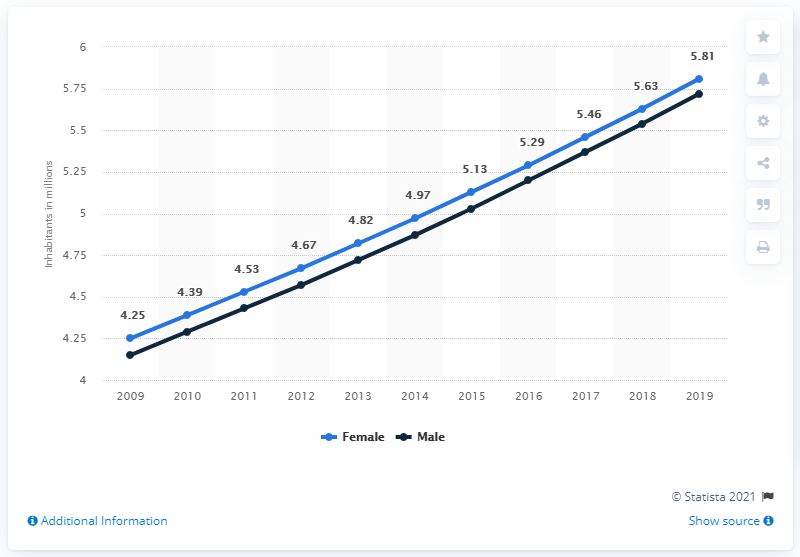List a handful of essential elements in this visual. According to data from 2019, the male population of Burundi was 5.72 million. In 2019, the female population of Burundi was 5.81 million. 